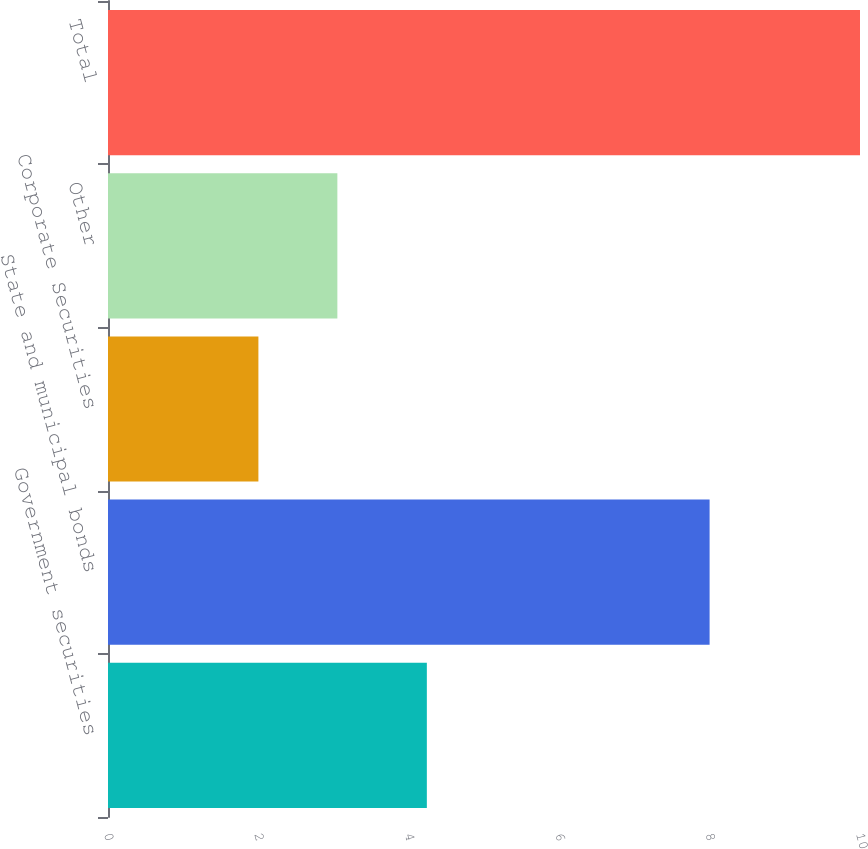<chart> <loc_0><loc_0><loc_500><loc_500><bar_chart><fcel>Government securities<fcel>State and municipal bonds<fcel>Corporate Securities<fcel>Other<fcel>Total<nl><fcel>4.24<fcel>8<fcel>2<fcel>3.05<fcel>10<nl></chart> 